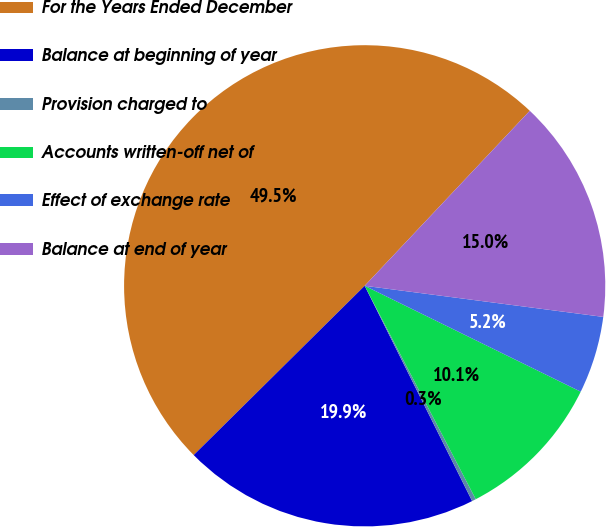Convert chart to OTSL. <chart><loc_0><loc_0><loc_500><loc_500><pie_chart><fcel>For the Years Ended December<fcel>Balance at beginning of year<fcel>Provision charged to<fcel>Accounts written-off net of<fcel>Effect of exchange rate<fcel>Balance at end of year<nl><fcel>49.46%<fcel>19.95%<fcel>0.27%<fcel>10.11%<fcel>5.19%<fcel>15.03%<nl></chart> 